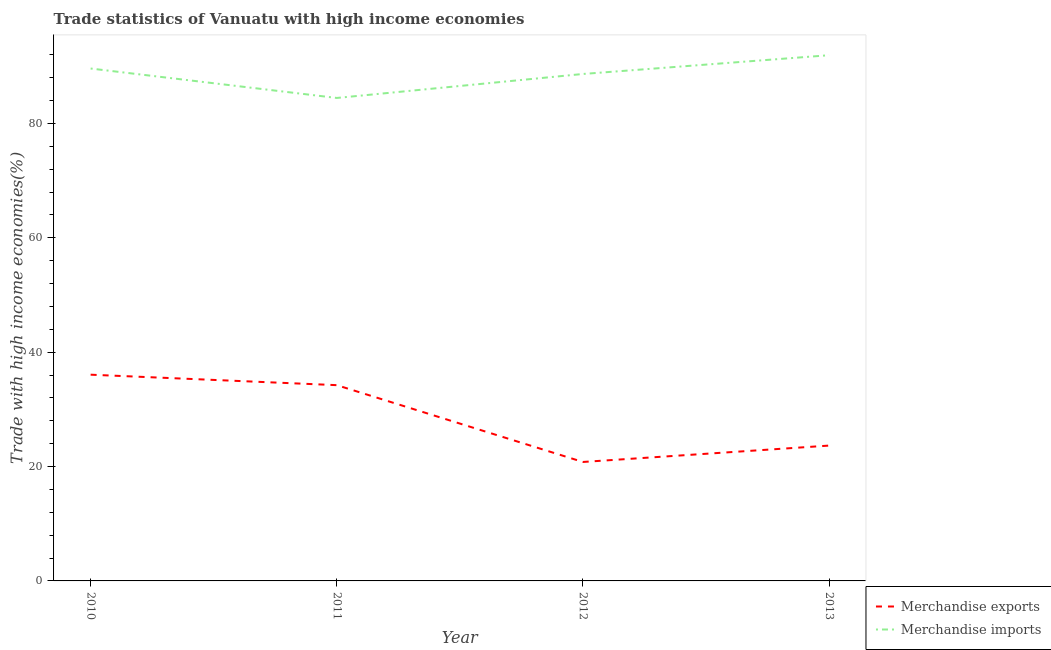Does the line corresponding to merchandise imports intersect with the line corresponding to merchandise exports?
Provide a succinct answer. No. What is the merchandise exports in 2012?
Provide a short and direct response. 20.81. Across all years, what is the maximum merchandise exports?
Your response must be concise. 36.07. Across all years, what is the minimum merchandise imports?
Your answer should be compact. 84.47. In which year was the merchandise exports minimum?
Provide a succinct answer. 2012. What is the total merchandise exports in the graph?
Give a very brief answer. 114.78. What is the difference between the merchandise imports in 2010 and that in 2013?
Provide a short and direct response. -2.33. What is the difference between the merchandise exports in 2010 and the merchandise imports in 2011?
Make the answer very short. -48.4. What is the average merchandise imports per year?
Offer a very short reply. 88.67. In the year 2012, what is the difference between the merchandise exports and merchandise imports?
Provide a short and direct response. -67.86. In how many years, is the merchandise exports greater than 28 %?
Your answer should be very brief. 2. What is the ratio of the merchandise imports in 2012 to that in 2013?
Your response must be concise. 0.96. Is the difference between the merchandise exports in 2010 and 2013 greater than the difference between the merchandise imports in 2010 and 2013?
Provide a succinct answer. Yes. What is the difference between the highest and the second highest merchandise exports?
Offer a very short reply. 1.83. What is the difference between the highest and the lowest merchandise imports?
Ensure brevity in your answer.  7.48. Where does the legend appear in the graph?
Provide a short and direct response. Bottom right. How many legend labels are there?
Keep it short and to the point. 2. What is the title of the graph?
Provide a short and direct response. Trade statistics of Vanuatu with high income economies. Does "Resident workers" appear as one of the legend labels in the graph?
Make the answer very short. No. What is the label or title of the X-axis?
Provide a short and direct response. Year. What is the label or title of the Y-axis?
Give a very brief answer. Trade with high income economies(%). What is the Trade with high income economies(%) of Merchandise exports in 2010?
Make the answer very short. 36.07. What is the Trade with high income economies(%) in Merchandise imports in 2010?
Keep it short and to the point. 89.62. What is the Trade with high income economies(%) in Merchandise exports in 2011?
Provide a succinct answer. 34.24. What is the Trade with high income economies(%) of Merchandise imports in 2011?
Offer a terse response. 84.47. What is the Trade with high income economies(%) of Merchandise exports in 2012?
Ensure brevity in your answer.  20.81. What is the Trade with high income economies(%) of Merchandise imports in 2012?
Make the answer very short. 88.66. What is the Trade with high income economies(%) of Merchandise exports in 2013?
Your response must be concise. 23.67. What is the Trade with high income economies(%) in Merchandise imports in 2013?
Your answer should be very brief. 91.95. Across all years, what is the maximum Trade with high income economies(%) in Merchandise exports?
Give a very brief answer. 36.07. Across all years, what is the maximum Trade with high income economies(%) of Merchandise imports?
Your response must be concise. 91.95. Across all years, what is the minimum Trade with high income economies(%) of Merchandise exports?
Your answer should be compact. 20.81. Across all years, what is the minimum Trade with high income economies(%) in Merchandise imports?
Give a very brief answer. 84.47. What is the total Trade with high income economies(%) in Merchandise exports in the graph?
Give a very brief answer. 114.78. What is the total Trade with high income economies(%) of Merchandise imports in the graph?
Give a very brief answer. 354.7. What is the difference between the Trade with high income economies(%) in Merchandise exports in 2010 and that in 2011?
Offer a terse response. 1.83. What is the difference between the Trade with high income economies(%) of Merchandise imports in 2010 and that in 2011?
Offer a very short reply. 5.15. What is the difference between the Trade with high income economies(%) in Merchandise exports in 2010 and that in 2012?
Offer a very short reply. 15.26. What is the difference between the Trade with high income economies(%) in Merchandise imports in 2010 and that in 2012?
Offer a terse response. 0.95. What is the difference between the Trade with high income economies(%) in Merchandise exports in 2010 and that in 2013?
Provide a succinct answer. 12.4. What is the difference between the Trade with high income economies(%) in Merchandise imports in 2010 and that in 2013?
Give a very brief answer. -2.33. What is the difference between the Trade with high income economies(%) of Merchandise exports in 2011 and that in 2012?
Make the answer very short. 13.43. What is the difference between the Trade with high income economies(%) of Merchandise imports in 2011 and that in 2012?
Make the answer very short. -4.19. What is the difference between the Trade with high income economies(%) in Merchandise exports in 2011 and that in 2013?
Your answer should be compact. 10.57. What is the difference between the Trade with high income economies(%) in Merchandise imports in 2011 and that in 2013?
Offer a terse response. -7.48. What is the difference between the Trade with high income economies(%) of Merchandise exports in 2012 and that in 2013?
Provide a succinct answer. -2.86. What is the difference between the Trade with high income economies(%) in Merchandise imports in 2012 and that in 2013?
Provide a succinct answer. -3.28. What is the difference between the Trade with high income economies(%) in Merchandise exports in 2010 and the Trade with high income economies(%) in Merchandise imports in 2011?
Provide a succinct answer. -48.4. What is the difference between the Trade with high income economies(%) in Merchandise exports in 2010 and the Trade with high income economies(%) in Merchandise imports in 2012?
Provide a short and direct response. -52.59. What is the difference between the Trade with high income economies(%) of Merchandise exports in 2010 and the Trade with high income economies(%) of Merchandise imports in 2013?
Offer a terse response. -55.88. What is the difference between the Trade with high income economies(%) in Merchandise exports in 2011 and the Trade with high income economies(%) in Merchandise imports in 2012?
Provide a short and direct response. -54.42. What is the difference between the Trade with high income economies(%) in Merchandise exports in 2011 and the Trade with high income economies(%) in Merchandise imports in 2013?
Offer a very short reply. -57.71. What is the difference between the Trade with high income economies(%) in Merchandise exports in 2012 and the Trade with high income economies(%) in Merchandise imports in 2013?
Your answer should be very brief. -71.14. What is the average Trade with high income economies(%) of Merchandise exports per year?
Keep it short and to the point. 28.7. What is the average Trade with high income economies(%) in Merchandise imports per year?
Offer a terse response. 88.67. In the year 2010, what is the difference between the Trade with high income economies(%) of Merchandise exports and Trade with high income economies(%) of Merchandise imports?
Offer a terse response. -53.55. In the year 2011, what is the difference between the Trade with high income economies(%) of Merchandise exports and Trade with high income economies(%) of Merchandise imports?
Keep it short and to the point. -50.23. In the year 2012, what is the difference between the Trade with high income economies(%) in Merchandise exports and Trade with high income economies(%) in Merchandise imports?
Make the answer very short. -67.86. In the year 2013, what is the difference between the Trade with high income economies(%) in Merchandise exports and Trade with high income economies(%) in Merchandise imports?
Your answer should be very brief. -68.28. What is the ratio of the Trade with high income economies(%) of Merchandise exports in 2010 to that in 2011?
Keep it short and to the point. 1.05. What is the ratio of the Trade with high income economies(%) in Merchandise imports in 2010 to that in 2011?
Ensure brevity in your answer.  1.06. What is the ratio of the Trade with high income economies(%) in Merchandise exports in 2010 to that in 2012?
Provide a short and direct response. 1.73. What is the ratio of the Trade with high income economies(%) of Merchandise imports in 2010 to that in 2012?
Offer a very short reply. 1.01. What is the ratio of the Trade with high income economies(%) in Merchandise exports in 2010 to that in 2013?
Your answer should be very brief. 1.52. What is the ratio of the Trade with high income economies(%) in Merchandise imports in 2010 to that in 2013?
Offer a very short reply. 0.97. What is the ratio of the Trade with high income economies(%) in Merchandise exports in 2011 to that in 2012?
Your response must be concise. 1.65. What is the ratio of the Trade with high income economies(%) of Merchandise imports in 2011 to that in 2012?
Offer a very short reply. 0.95. What is the ratio of the Trade with high income economies(%) in Merchandise exports in 2011 to that in 2013?
Give a very brief answer. 1.45. What is the ratio of the Trade with high income economies(%) in Merchandise imports in 2011 to that in 2013?
Offer a very short reply. 0.92. What is the ratio of the Trade with high income economies(%) in Merchandise exports in 2012 to that in 2013?
Ensure brevity in your answer.  0.88. What is the ratio of the Trade with high income economies(%) of Merchandise imports in 2012 to that in 2013?
Keep it short and to the point. 0.96. What is the difference between the highest and the second highest Trade with high income economies(%) in Merchandise exports?
Make the answer very short. 1.83. What is the difference between the highest and the second highest Trade with high income economies(%) of Merchandise imports?
Offer a terse response. 2.33. What is the difference between the highest and the lowest Trade with high income economies(%) in Merchandise exports?
Offer a terse response. 15.26. What is the difference between the highest and the lowest Trade with high income economies(%) of Merchandise imports?
Offer a terse response. 7.48. 